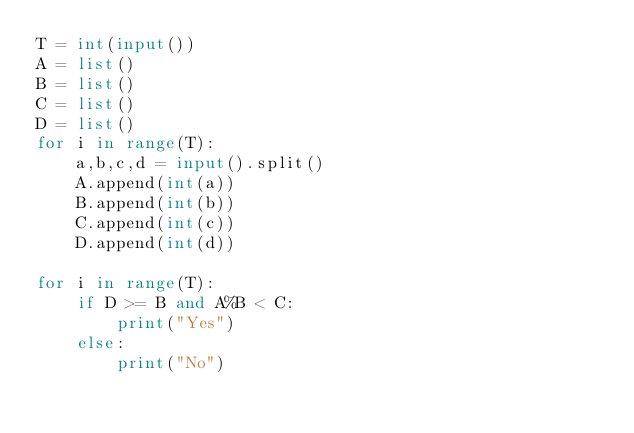<code> <loc_0><loc_0><loc_500><loc_500><_Python_>T = int(input())
A = list()
B = list()
C = list()
D = list()
for i in range(T):
    a,b,c,d = input().split()
    A.append(int(a))
    B.append(int(b))
    C.append(int(c))
    D.append(int(d))

for i in range(T):
    if D >= B and A%B < C:
        print("Yes")
    else:
        print("No")</code> 